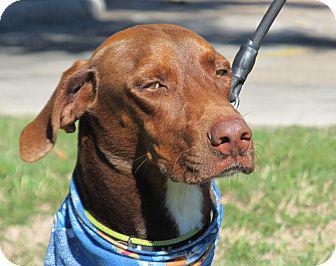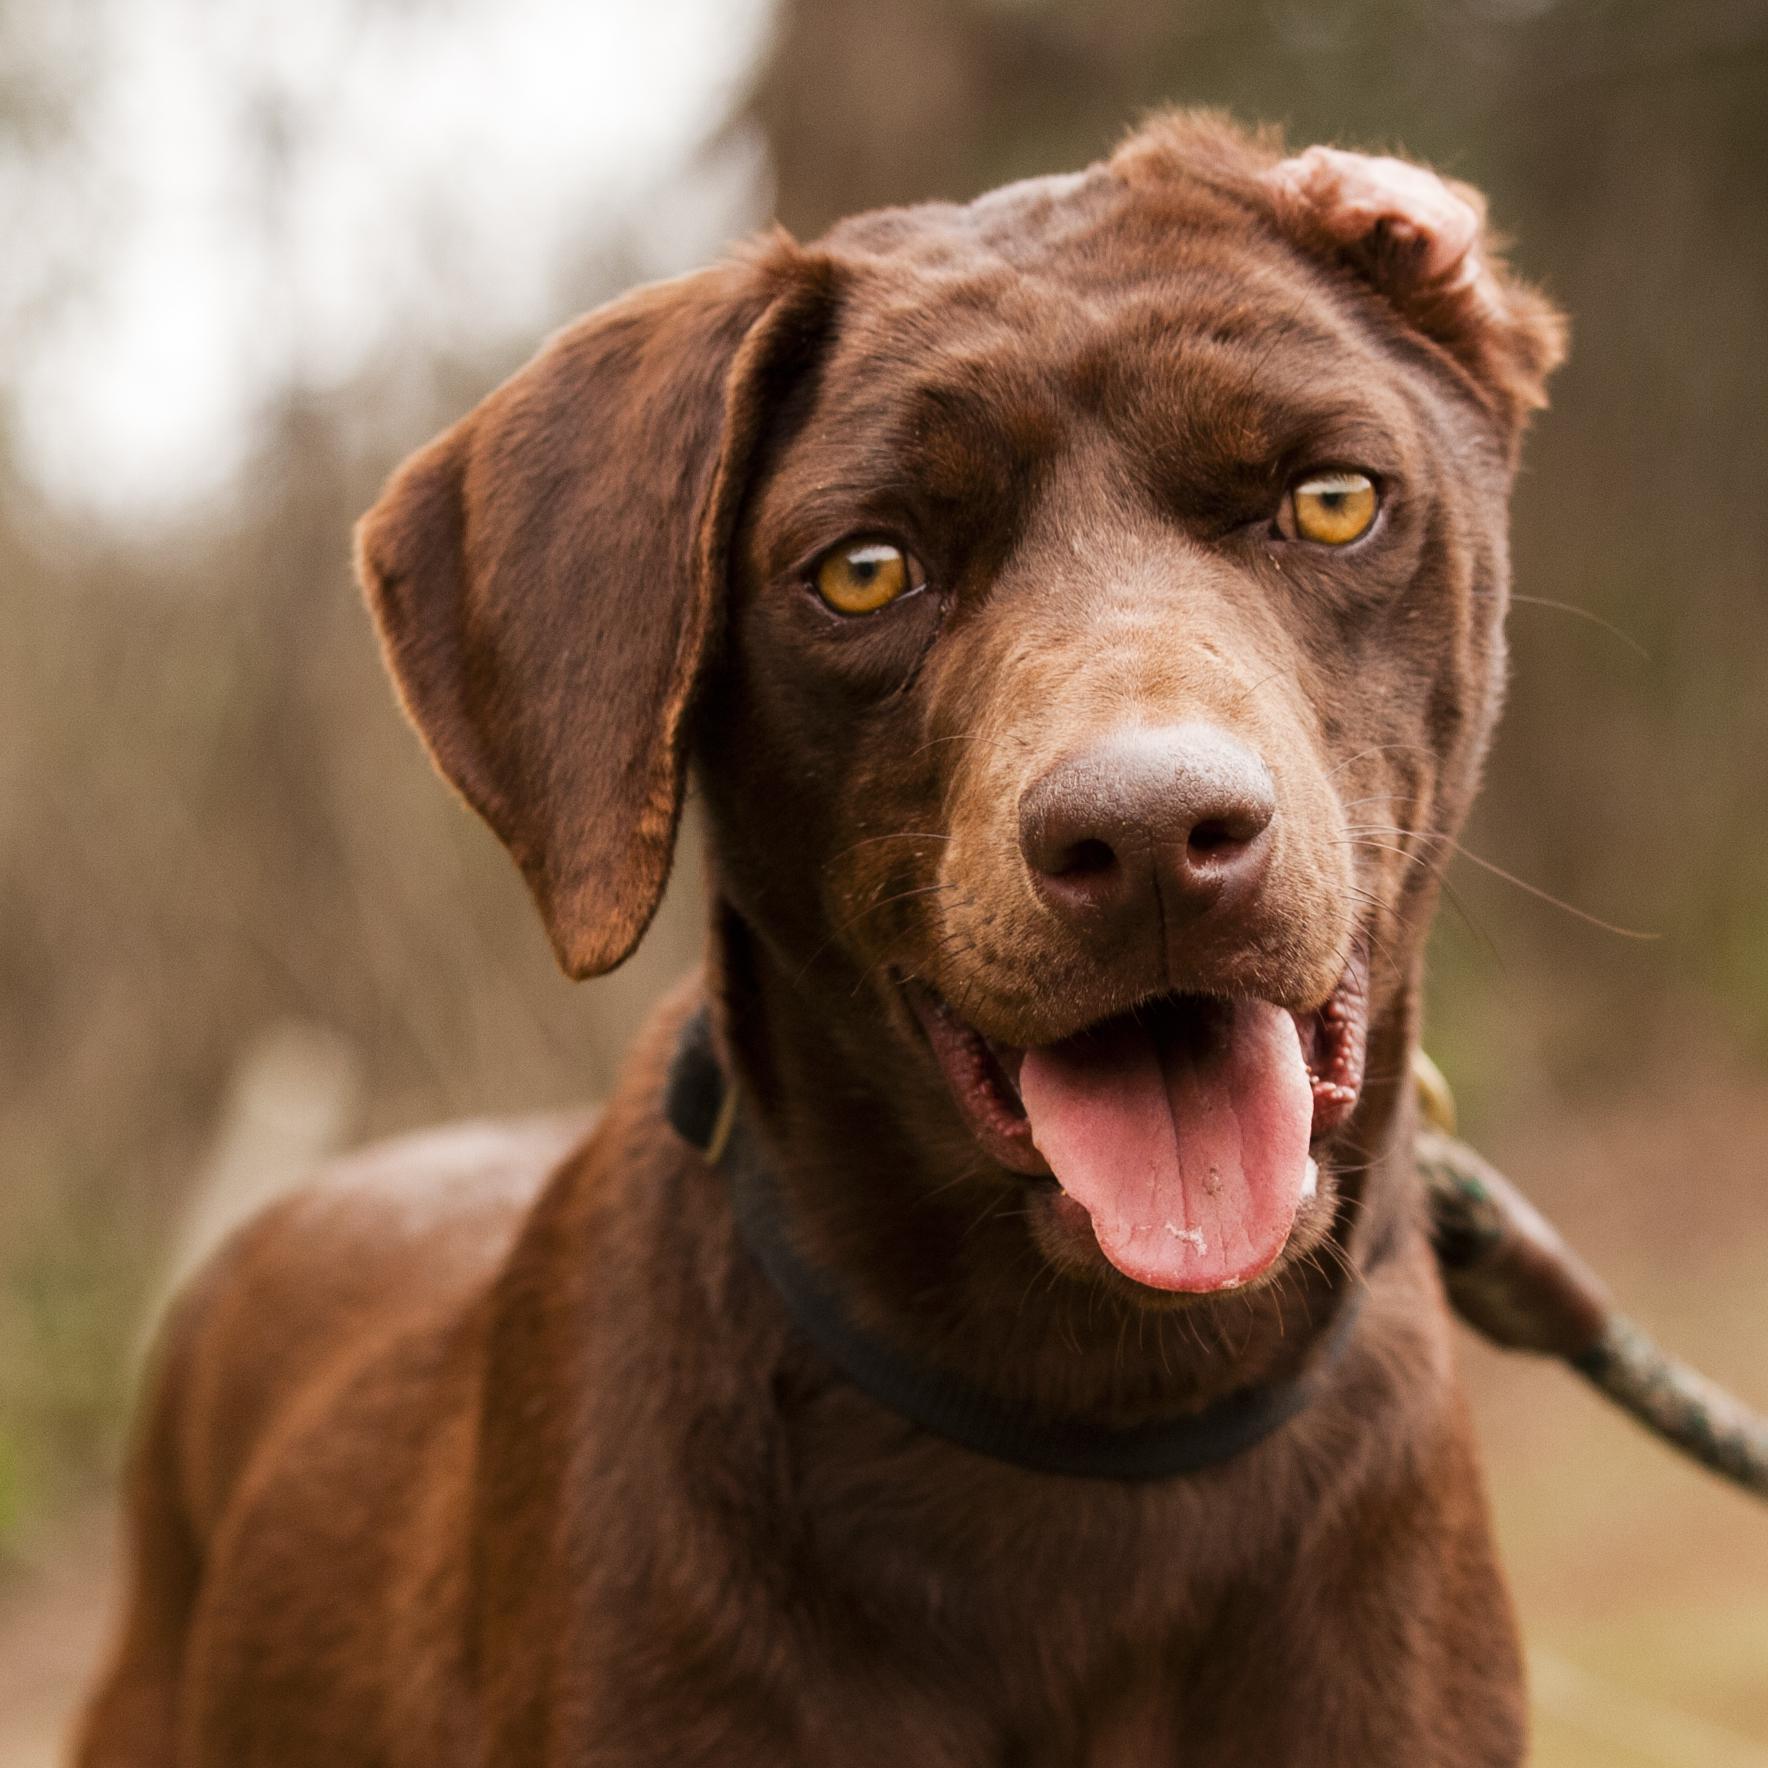The first image is the image on the left, the second image is the image on the right. Considering the images on both sides, is "At least one dog is on a leash." valid? Answer yes or no. Yes. The first image is the image on the left, the second image is the image on the right. For the images shown, is this caption "Each image contains one dog, and the righthand dog has its pink tongue extended past its teeth." true? Answer yes or no. Yes. 